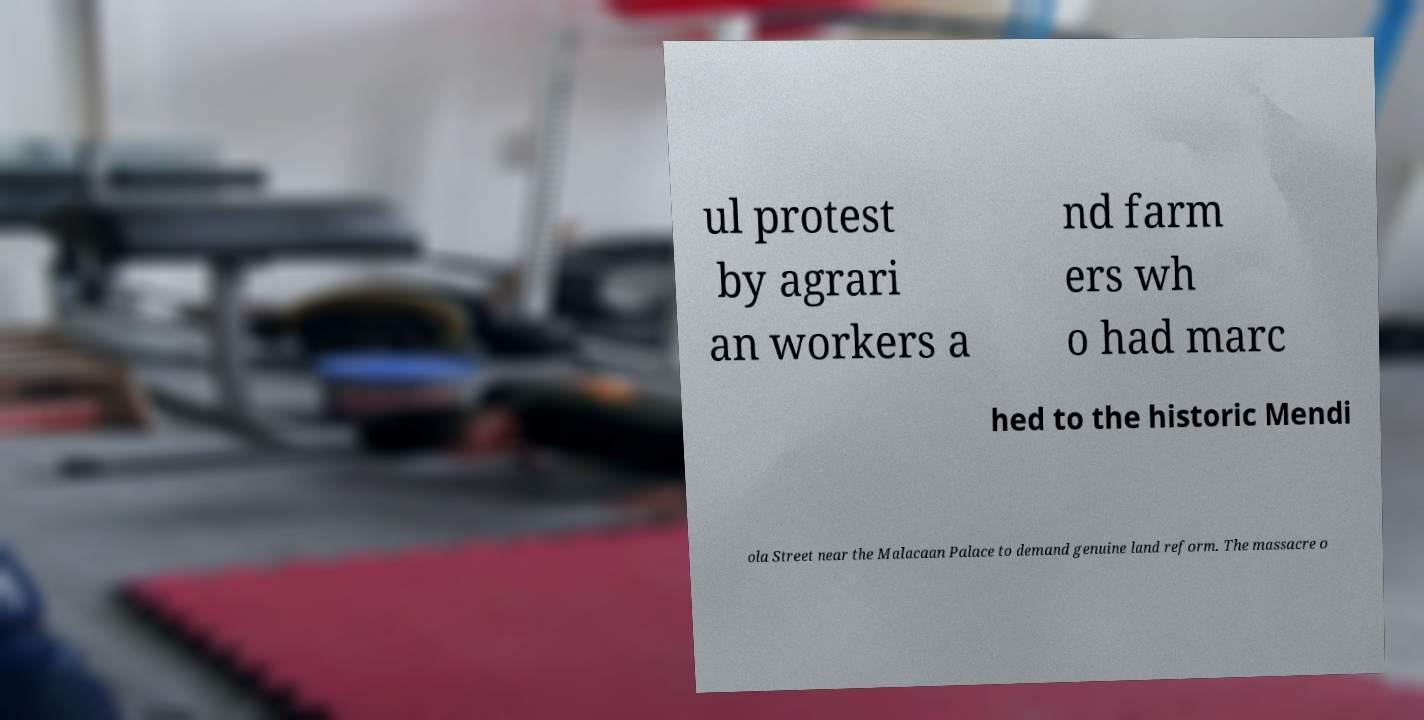Could you extract and type out the text from this image? ul protest by agrari an workers a nd farm ers wh o had marc hed to the historic Mendi ola Street near the Malacaan Palace to demand genuine land reform. The massacre o 